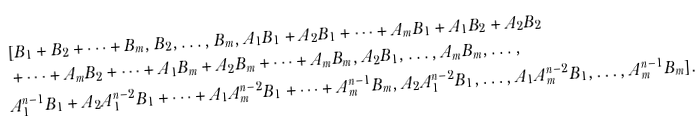Convert formula to latex. <formula><loc_0><loc_0><loc_500><loc_500>& [ B _ { 1 } + B _ { 2 } + \dots + B _ { m } , B _ { 2 } , \dots , B _ { m } , A _ { 1 } B _ { 1 } + A _ { 2 } B _ { 1 } + \dots + A _ { m } B _ { 1 } + A _ { 1 } B _ { 2 } + A _ { 2 } B _ { 2 } \\ & + \dots + A _ { m } B _ { 2 } + \dots + A _ { 1 } B _ { m } + A _ { 2 } B _ { m } + \dots + A _ { m } B _ { m } , A _ { 2 } B _ { 1 } , \dots , A _ { m } B _ { m } , \dots , \\ & A _ { 1 } ^ { n - 1 } B _ { 1 } + A _ { 2 } A _ { 1 } ^ { n - 2 } B _ { 1 } + \dots + A _ { 1 } A _ { m } ^ { n - 2 } B _ { 1 } + \dots + A _ { m } ^ { n - 1 } B _ { m } , A _ { 2 } A _ { 1 } ^ { n - 2 } B _ { 1 } , \dots , A _ { 1 } A _ { m } ^ { n - 2 } B _ { 1 } , \dots , A _ { m } ^ { n - 1 } B _ { m } ] .</formula> 